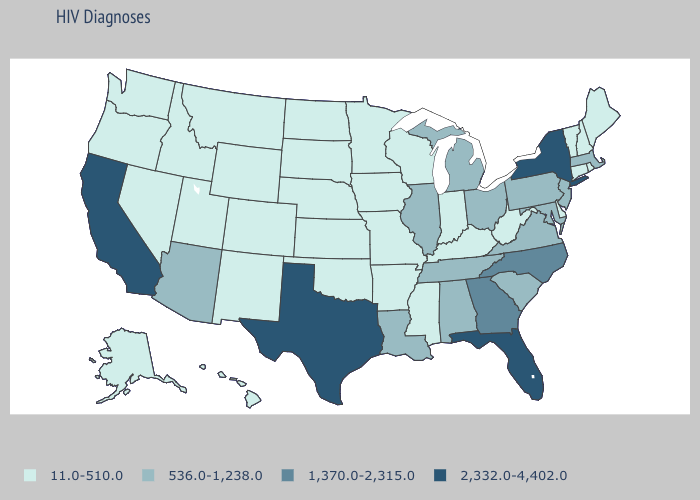Does New Jersey have the highest value in the Northeast?
Write a very short answer. No. What is the highest value in the West ?
Answer briefly. 2,332.0-4,402.0. What is the value of California?
Answer briefly. 2,332.0-4,402.0. What is the highest value in the USA?
Give a very brief answer. 2,332.0-4,402.0. Is the legend a continuous bar?
Write a very short answer. No. Name the states that have a value in the range 536.0-1,238.0?
Short answer required. Alabama, Arizona, Illinois, Louisiana, Maryland, Massachusetts, Michigan, New Jersey, Ohio, Pennsylvania, South Carolina, Tennessee, Virginia. Name the states that have a value in the range 1,370.0-2,315.0?
Give a very brief answer. Georgia, North Carolina. Name the states that have a value in the range 11.0-510.0?
Answer briefly. Alaska, Arkansas, Colorado, Connecticut, Delaware, Hawaii, Idaho, Indiana, Iowa, Kansas, Kentucky, Maine, Minnesota, Mississippi, Missouri, Montana, Nebraska, Nevada, New Hampshire, New Mexico, North Dakota, Oklahoma, Oregon, Rhode Island, South Dakota, Utah, Vermont, Washington, West Virginia, Wisconsin, Wyoming. What is the value of Vermont?
Short answer required. 11.0-510.0. Name the states that have a value in the range 536.0-1,238.0?
Keep it brief. Alabama, Arizona, Illinois, Louisiana, Maryland, Massachusetts, Michigan, New Jersey, Ohio, Pennsylvania, South Carolina, Tennessee, Virginia. What is the value of Kentucky?
Concise answer only. 11.0-510.0. What is the highest value in the USA?
Give a very brief answer. 2,332.0-4,402.0. Does Hawaii have the highest value in the USA?
Keep it brief. No. What is the lowest value in the West?
Be succinct. 11.0-510.0. 